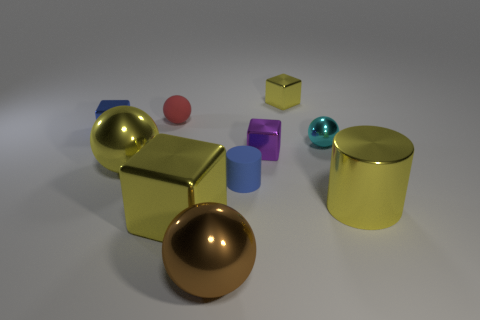The sphere that is the same color as the big cube is what size?
Give a very brief answer. Large. The cylinder on the left side of the block that is behind the blue metal object on the left side of the purple metallic block is what color?
Your response must be concise. Blue. Does the purple thing have the same shape as the big brown shiny thing?
Make the answer very short. No. The large cylinder that is the same material as the tiny cyan ball is what color?
Offer a very short reply. Yellow. What number of things are either big yellow metallic objects that are behind the small matte cylinder or purple things?
Provide a succinct answer. 2. There is a yellow cube left of the purple block; what is its size?
Ensure brevity in your answer.  Large. Does the yellow ball have the same size as the yellow shiny cube behind the cyan ball?
Offer a terse response. No. What is the color of the large ball that is in front of the large shiny thing that is to the right of the cyan metallic ball?
Your answer should be compact. Brown. What number of other objects are there of the same color as the tiny matte cylinder?
Offer a terse response. 1. What size is the brown thing?
Provide a short and direct response. Large. 